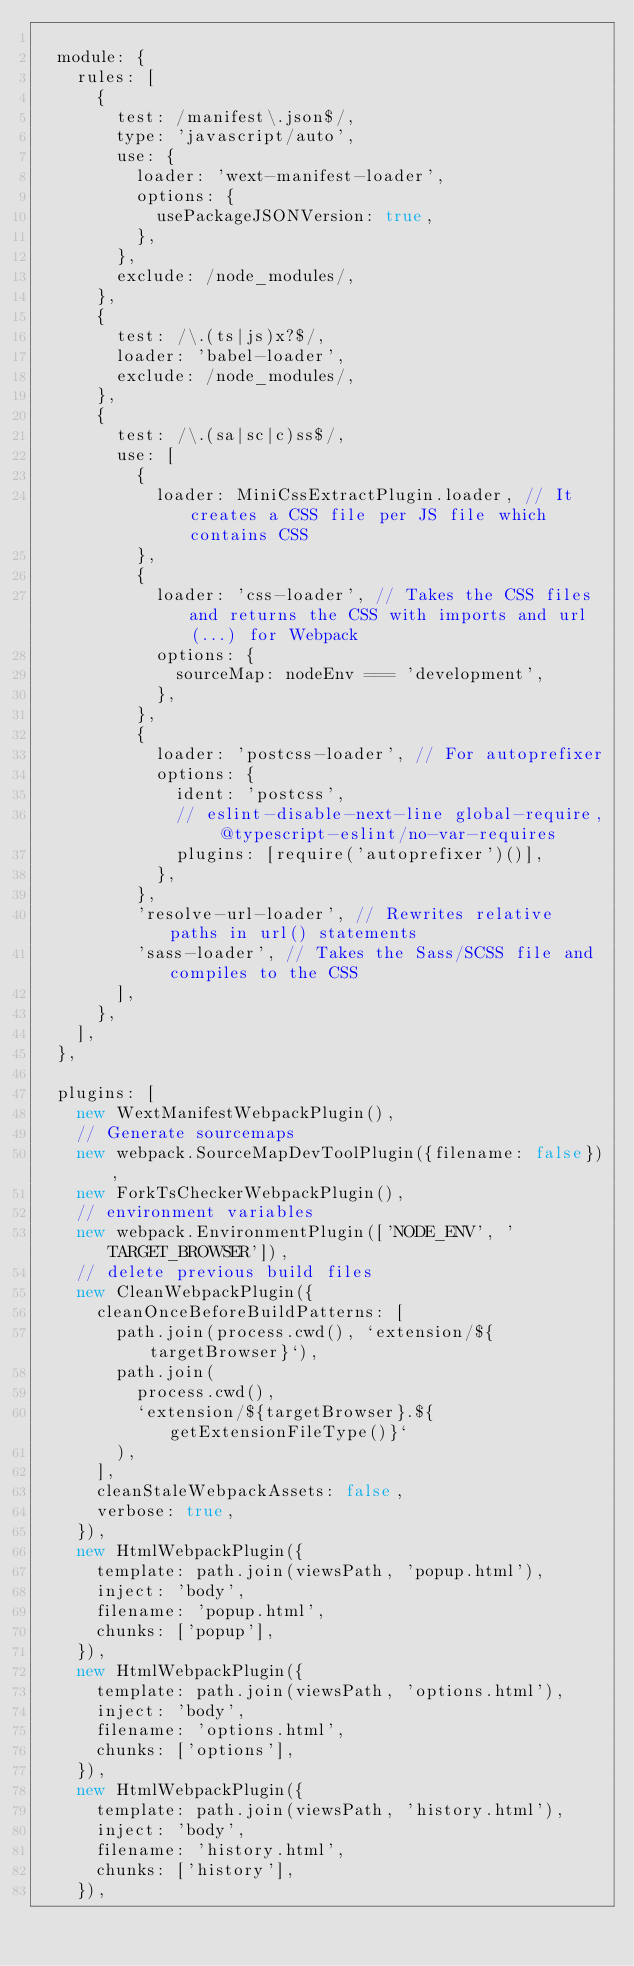<code> <loc_0><loc_0><loc_500><loc_500><_JavaScript_>
  module: {
    rules: [
      {
        test: /manifest\.json$/,
        type: 'javascript/auto',
        use: {
          loader: 'wext-manifest-loader',
          options: {
            usePackageJSONVersion: true,
          },
        },
        exclude: /node_modules/,
      },
      {
        test: /\.(ts|js)x?$/,
        loader: 'babel-loader',
        exclude: /node_modules/,
      },
      {
        test: /\.(sa|sc|c)ss$/,
        use: [
          {
            loader: MiniCssExtractPlugin.loader, // It creates a CSS file per JS file which contains CSS
          },
          {
            loader: 'css-loader', // Takes the CSS files and returns the CSS with imports and url(...) for Webpack
            options: {
              sourceMap: nodeEnv === 'development',
            },
          },
          {
            loader: 'postcss-loader', // For autoprefixer
            options: {
              ident: 'postcss',
              // eslint-disable-next-line global-require, @typescript-eslint/no-var-requires
              plugins: [require('autoprefixer')()],
            },
          },
          'resolve-url-loader', // Rewrites relative paths in url() statements
          'sass-loader', // Takes the Sass/SCSS file and compiles to the CSS
        ],
      },
    ],
  },

  plugins: [
    new WextManifestWebpackPlugin(),
    // Generate sourcemaps
    new webpack.SourceMapDevToolPlugin({filename: false}),
    new ForkTsCheckerWebpackPlugin(),
    // environment variables
    new webpack.EnvironmentPlugin(['NODE_ENV', 'TARGET_BROWSER']),
    // delete previous build files
    new CleanWebpackPlugin({
      cleanOnceBeforeBuildPatterns: [
        path.join(process.cwd(), `extension/${targetBrowser}`),
        path.join(
          process.cwd(),
          `extension/${targetBrowser}.${getExtensionFileType()}`
        ),
      ],
      cleanStaleWebpackAssets: false,
      verbose: true,
    }),
    new HtmlWebpackPlugin({
      template: path.join(viewsPath, 'popup.html'),
      inject: 'body',
      filename: 'popup.html',
      chunks: ['popup'],
    }),
    new HtmlWebpackPlugin({
      template: path.join(viewsPath, 'options.html'),
      inject: 'body',
      filename: 'options.html',
      chunks: ['options'],
    }),
    new HtmlWebpackPlugin({
      template: path.join(viewsPath, 'history.html'),
      inject: 'body',
      filename: 'history.html',
      chunks: ['history'],
    }),</code> 